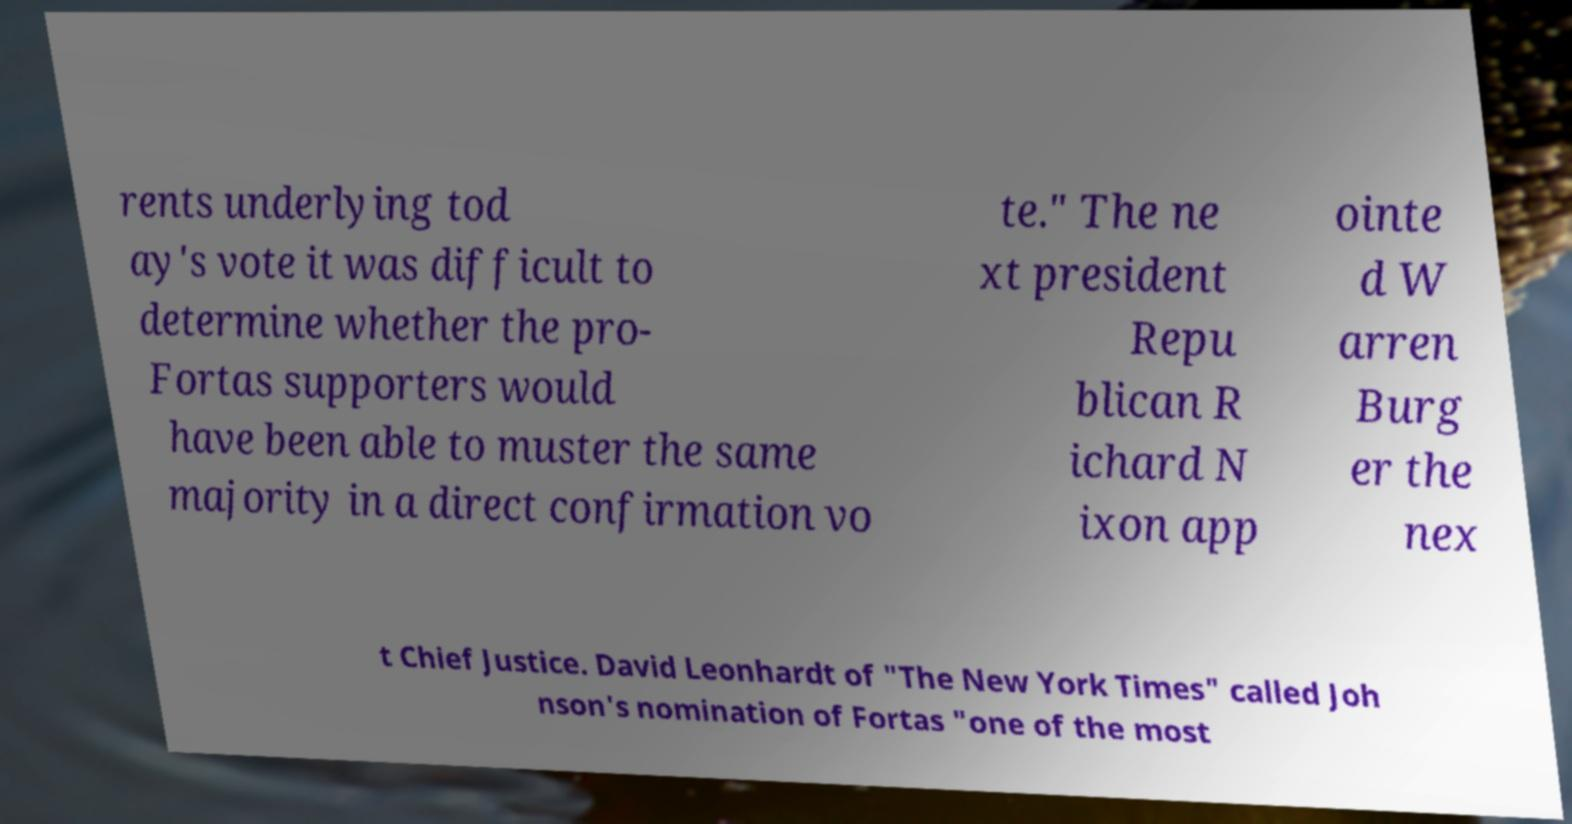Could you extract and type out the text from this image? rents underlying tod ay's vote it was difficult to determine whether the pro- Fortas supporters would have been able to muster the same majority in a direct confirmation vo te." The ne xt president Repu blican R ichard N ixon app ointe d W arren Burg er the nex t Chief Justice. David Leonhardt of "The New York Times" called Joh nson's nomination of Fortas "one of the most 